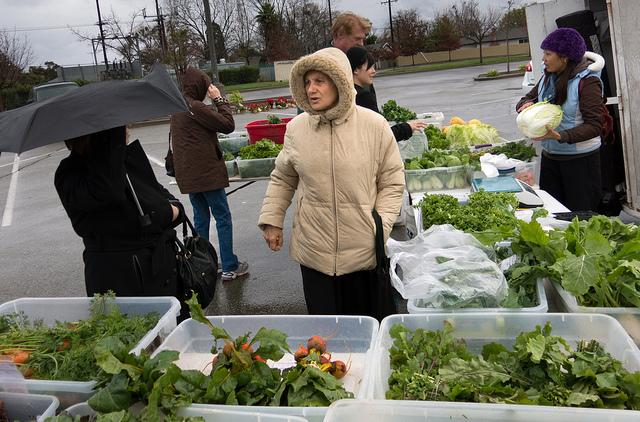What is the woman on the right holding in her hand? lettuce 